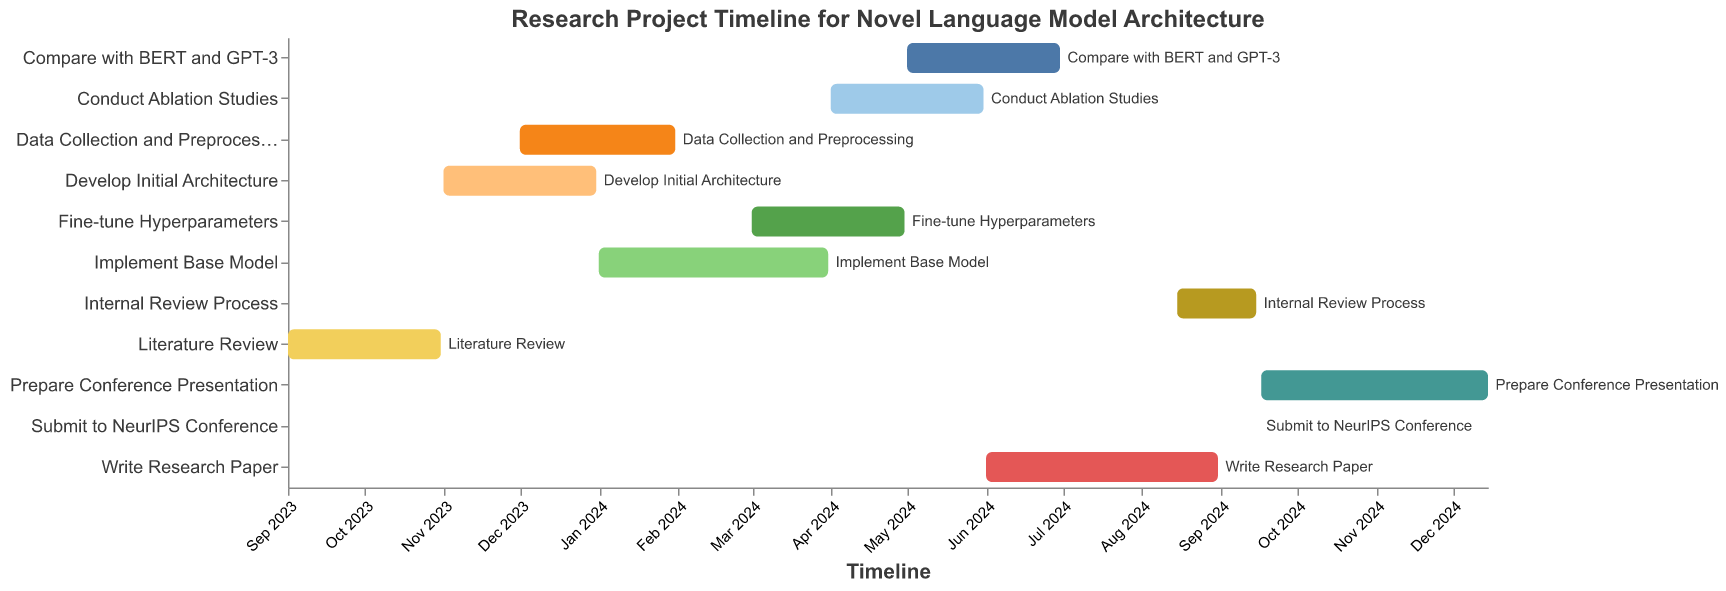What is the title of the Gantt Chart? The title of the chart is usually found at the top and clearly indicates the purpose or subject of the Gantt chart. In this case, it reads "Research Project Timeline for Novel Language Model Architecture".
Answer: Research Project Timeline for Novel Language Model Architecture When does the task 'Implement Base Model' start and end? Look for the bar in the chart labeled 'Implement Base Model' and check the start and end dates that are aligned with this bar. It starts in January 2024 and ends in March 2024.
Answer: January 2024 to March 2024 Which tasks overlap with 'Data Collection and Preprocessing'? Find the bar labeled 'Data Collection and Preprocessing' and identify other bars that have overlapping timelines (December 2023 to January 2024). The tasks 'Develop Initial Architecture' (overlaps in December 2023) and 'Implement Base Model' (overlaps in January 2024) are overlapping.
Answer: Develop Initial Architecture, Implement Base Model Which task has the shortest duration, and what is its duration? Identify each bar's start and end dates. The shortest duration corresponds to the smallest time span, which is 'Submit to NeurIPS Conference' lasting just one day on September 16, 2024.
Answer: Submit to NeurIPS Conference, 1 day How long is the 'Prepare Conference Presentation' task? Locate the bar labeled 'Prepare Conference Presentation' and calculate the time between the start (September 17, 2024) and the end (December 15, 2024). The duration is approximately three months.
Answer: Approximately three months What is the total duration from the beginning of the 'Literature Review' to the end of the 'Prepare Conference Presentation'? Find the start date of the earliest task 'Literature Review' (September 1, 2023) and the end date of the latest task 'Prepare Conference Presentation' (December 15, 2024). Calculate the span between these two dates.
Answer: Approximately 15.5 months Which tasks are carried out in April 2024? Identify the tasks whose bars cover April 2024. These are 'Fine-tune Hyperparameters' and 'Conduct Ablation Studies', as both tasks include the month of April in their timelines.
Answer: Fine-tune Hyperparameters, Conduct Ablation Studies Does any task start and end within 2023? Check the timelines of all tasks to see if any task has both start and end dates within 2023. The task 'Develop Initial Architecture' starts on November 1, 2023, and ends on December 31, 2023.
Answer: Develop Initial Architecture Which tasks extend beyond six months? Calculate the durations of all tasks and identify those exceeding six months. 'Prepare Conference Presentation' extends from September 17, 2024, to December 15, 2024, which is about three months, so none of the tasks exceed six months.
Answer: None 